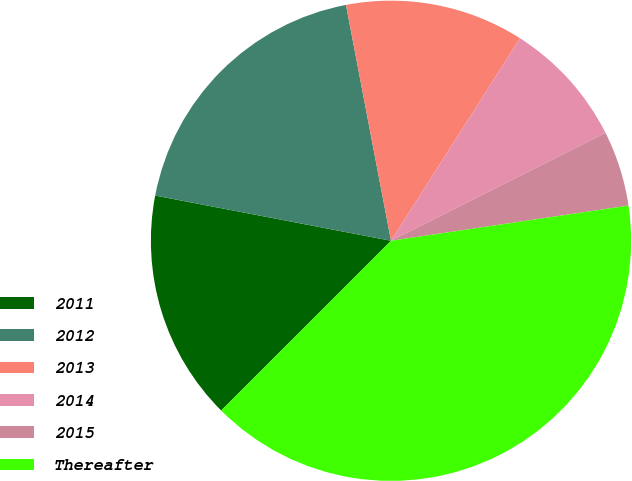<chart> <loc_0><loc_0><loc_500><loc_500><pie_chart><fcel>2011<fcel>2012<fcel>2013<fcel>2014<fcel>2015<fcel>Thereafter<nl><fcel>15.51%<fcel>18.98%<fcel>12.03%<fcel>8.55%<fcel>5.08%<fcel>39.84%<nl></chart> 